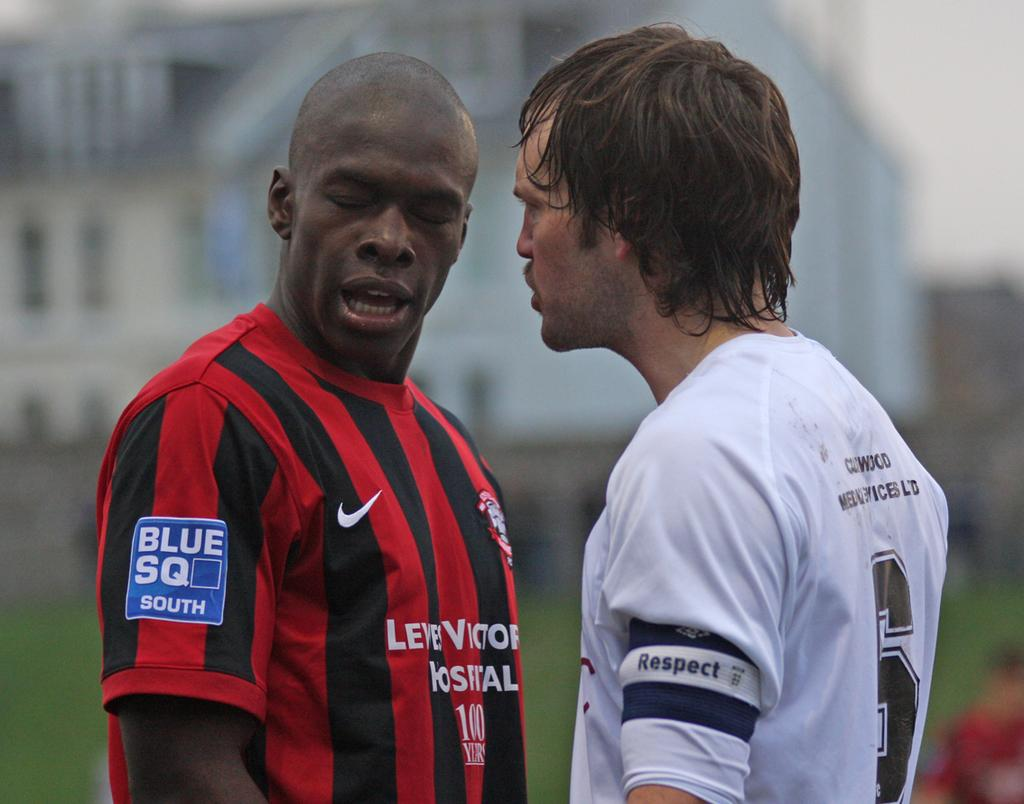<image>
Provide a brief description of the given image. A man wearing a red and black soccer jersey with a BLUE SQ SOUTH logo on his right sleeve gets into an argument with an opposing team's player. 